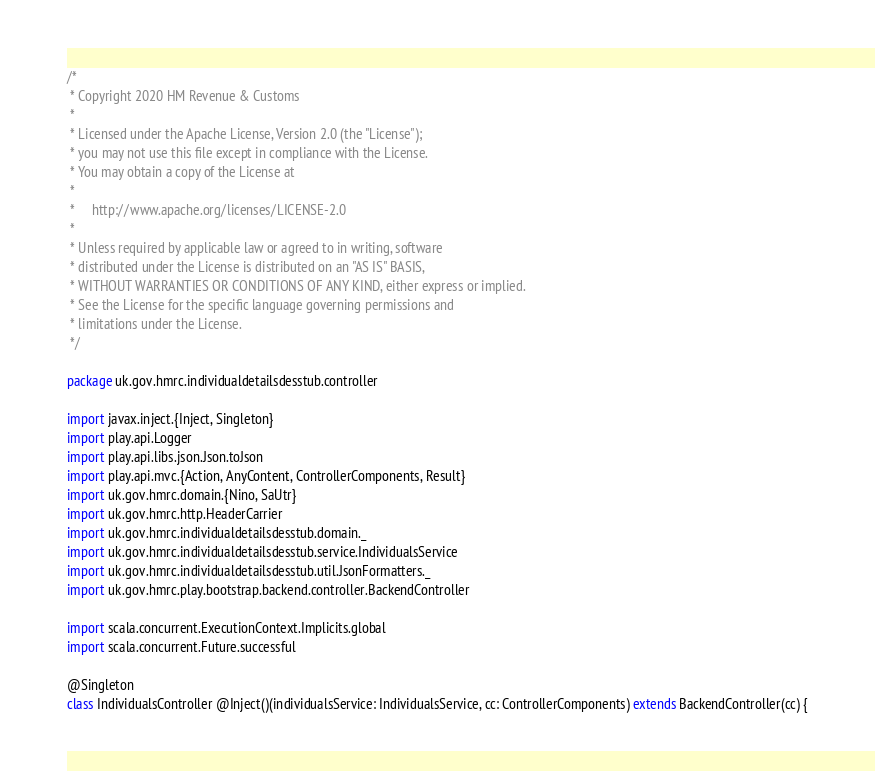Convert code to text. <code><loc_0><loc_0><loc_500><loc_500><_Scala_>/*
 * Copyright 2020 HM Revenue & Customs
 *
 * Licensed under the Apache License, Version 2.0 (the "License");
 * you may not use this file except in compliance with the License.
 * You may obtain a copy of the License at
 *
 *     http://www.apache.org/licenses/LICENSE-2.0
 *
 * Unless required by applicable law or agreed to in writing, software
 * distributed under the License is distributed on an "AS IS" BASIS,
 * WITHOUT WARRANTIES OR CONDITIONS OF ANY KIND, either express or implied.
 * See the License for the specific language governing permissions and
 * limitations under the License.
 */

package uk.gov.hmrc.individualdetailsdesstub.controller

import javax.inject.{Inject, Singleton}
import play.api.Logger
import play.api.libs.json.Json.toJson
import play.api.mvc.{Action, AnyContent, ControllerComponents, Result}
import uk.gov.hmrc.domain.{Nino, SaUtr}
import uk.gov.hmrc.http.HeaderCarrier
import uk.gov.hmrc.individualdetailsdesstub.domain._
import uk.gov.hmrc.individualdetailsdesstub.service.IndividualsService
import uk.gov.hmrc.individualdetailsdesstub.util.JsonFormatters._
import uk.gov.hmrc.play.bootstrap.backend.controller.BackendController

import scala.concurrent.ExecutionContext.Implicits.global
import scala.concurrent.Future.successful

@Singleton
class IndividualsController @Inject()(individualsService: IndividualsService, cc: ControllerComponents) extends BackendController(cc) {
</code> 